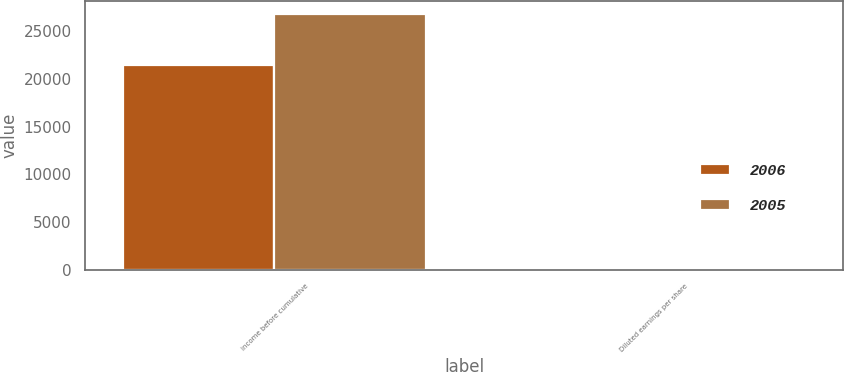<chart> <loc_0><loc_0><loc_500><loc_500><stacked_bar_chart><ecel><fcel>income before cumulative<fcel>Diluted earnings per share<nl><fcel>2006<fcel>21446<fcel>0.3<nl><fcel>2005<fcel>26845<fcel>0.38<nl></chart> 